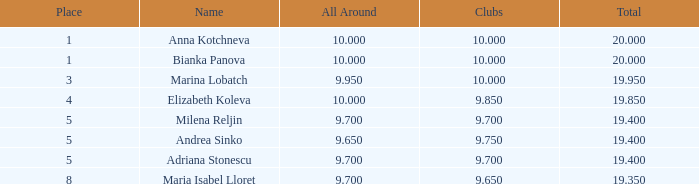Which clubs rank higher than 5 and have an overall score above 9.7 at the lowest level? None. Can you give me this table as a dict? {'header': ['Place', 'Name', 'All Around', 'Clubs', 'Total'], 'rows': [['1', 'Anna Kotchneva', '10.000', '10.000', '20.000'], ['1', 'Bianka Panova', '10.000', '10.000', '20.000'], ['3', 'Marina Lobatch', '9.950', '10.000', '19.950'], ['4', 'Elizabeth Koleva', '10.000', '9.850', '19.850'], ['5', 'Milena Reljin', '9.700', '9.700', '19.400'], ['5', 'Andrea Sinko', '9.650', '9.750', '19.400'], ['5', 'Adriana Stonescu', '9.700', '9.700', '19.400'], ['8', 'Maria Isabel Lloret', '9.700', '9.650', '19.350']]} 